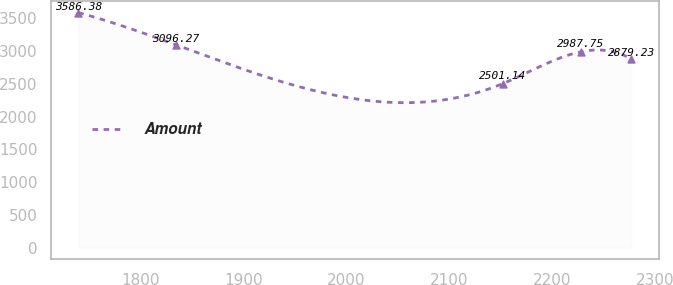Convert chart. <chart><loc_0><loc_0><loc_500><loc_500><line_chart><ecel><fcel>Amount<nl><fcel>1739.37<fcel>3586.38<nl><fcel>1834<fcel>3096.27<nl><fcel>2152.04<fcel>2501.14<nl><fcel>2227.89<fcel>2987.75<nl><fcel>2277.27<fcel>2879.23<nl></chart> 